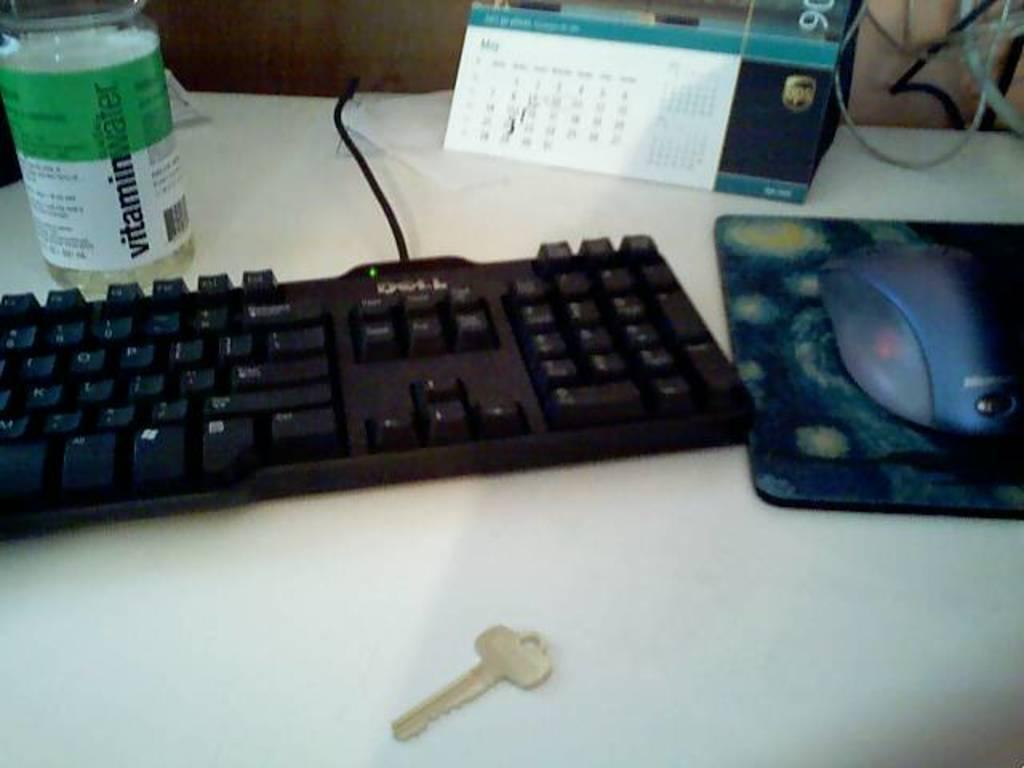<image>
Give a short and clear explanation of the subsequent image. A bottle of Vitamin Water sits on a desk next to a computer keyboard. 